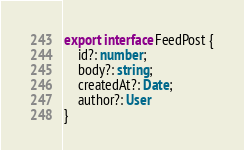Convert code to text. <code><loc_0><loc_0><loc_500><loc_500><_TypeScript_>export interface FeedPost {
    id?: number;
    body?: string;
    createdAt?: Date;
    author?: User
}</code> 